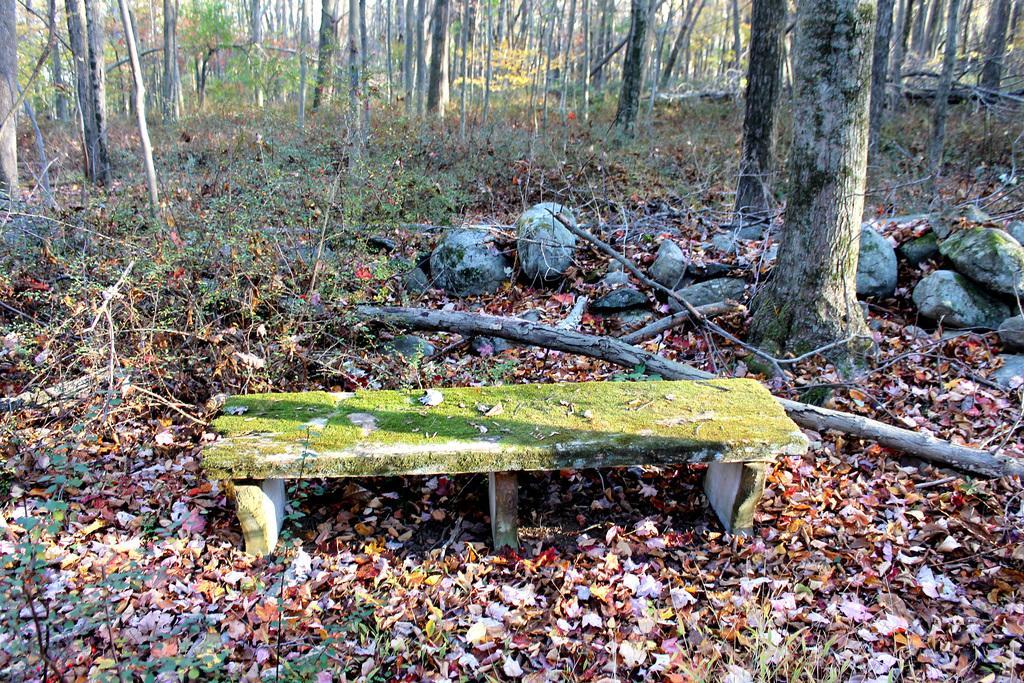Describe this image in one or two sentences. In this image there is a bench on a land, in the background there are stones and trees. 